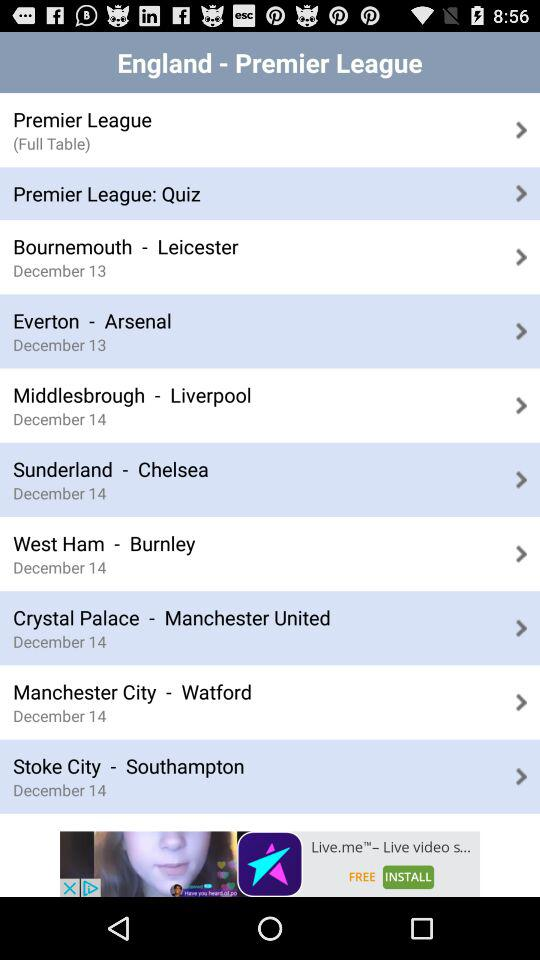What date is mentioned for Stoke City-Southampton? The mentioned date is December 14. 